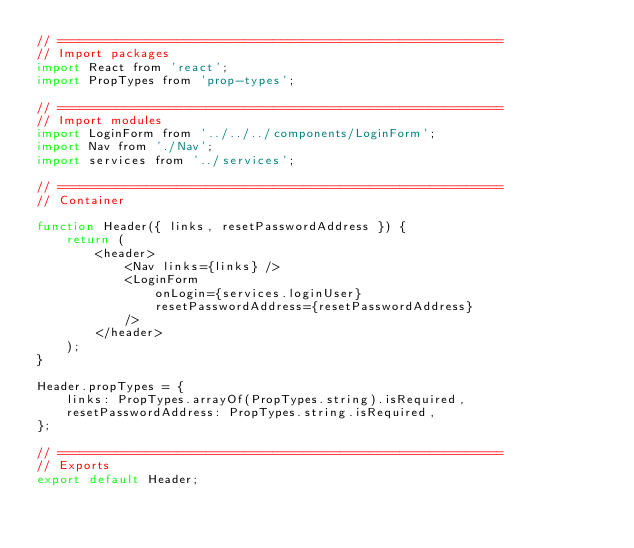Convert code to text. <code><loc_0><loc_0><loc_500><loc_500><_JavaScript_>// ============================================================
// Import packages
import React from 'react';
import PropTypes from 'prop-types';

// ============================================================
// Import modules
import LoginForm from '../../../components/LoginForm';
import Nav from './Nav';
import services from '../services';

// ============================================================
// Container

function Header({ links, resetPasswordAddress }) {
    return (
        <header>
            <Nav links={links} />
            <LoginForm
                onLogin={services.loginUser}
                resetPasswordAddress={resetPasswordAddress}
            />
        </header>
    );
}

Header.propTypes = {
    links: PropTypes.arrayOf(PropTypes.string).isRequired,
    resetPasswordAddress: PropTypes.string.isRequired,
};

// ============================================================
// Exports
export default Header;
</code> 